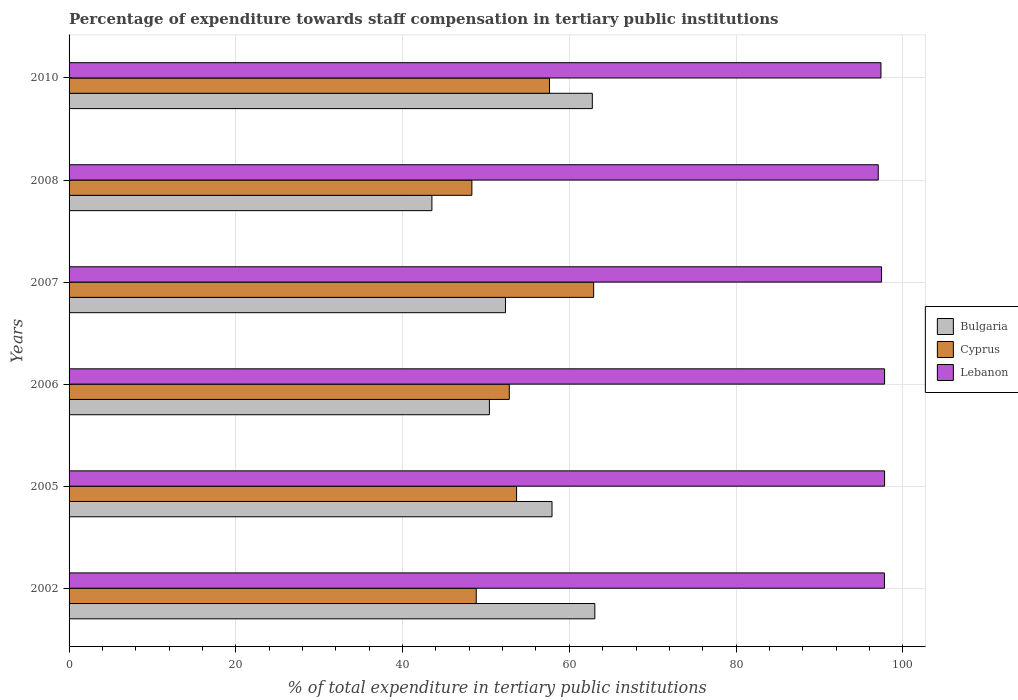Are the number of bars on each tick of the Y-axis equal?
Make the answer very short. Yes. How many bars are there on the 5th tick from the top?
Your answer should be compact. 3. How many bars are there on the 1st tick from the bottom?
Provide a succinct answer. 3. What is the label of the 4th group of bars from the top?
Give a very brief answer. 2006. What is the percentage of expenditure towards staff compensation in Cyprus in 2002?
Provide a short and direct response. 48.84. Across all years, what is the maximum percentage of expenditure towards staff compensation in Lebanon?
Provide a succinct answer. 97.81. Across all years, what is the minimum percentage of expenditure towards staff compensation in Lebanon?
Provide a short and direct response. 97.05. In which year was the percentage of expenditure towards staff compensation in Bulgaria minimum?
Make the answer very short. 2008. What is the total percentage of expenditure towards staff compensation in Lebanon in the graph?
Ensure brevity in your answer.  585.31. What is the difference between the percentage of expenditure towards staff compensation in Cyprus in 2006 and that in 2010?
Make the answer very short. -4.82. What is the difference between the percentage of expenditure towards staff compensation in Lebanon in 2006 and the percentage of expenditure towards staff compensation in Cyprus in 2007?
Make the answer very short. 34.89. What is the average percentage of expenditure towards staff compensation in Cyprus per year?
Your answer should be very brief. 54.03. In the year 2010, what is the difference between the percentage of expenditure towards staff compensation in Bulgaria and percentage of expenditure towards staff compensation in Cyprus?
Make the answer very short. 5.14. In how many years, is the percentage of expenditure towards staff compensation in Bulgaria greater than 32 %?
Ensure brevity in your answer.  6. What is the ratio of the percentage of expenditure towards staff compensation in Cyprus in 2002 to that in 2007?
Give a very brief answer. 0.78. Is the difference between the percentage of expenditure towards staff compensation in Bulgaria in 2006 and 2007 greater than the difference between the percentage of expenditure towards staff compensation in Cyprus in 2006 and 2007?
Ensure brevity in your answer.  Yes. What is the difference between the highest and the second highest percentage of expenditure towards staff compensation in Lebanon?
Your answer should be compact. 0. What is the difference between the highest and the lowest percentage of expenditure towards staff compensation in Lebanon?
Offer a terse response. 0.76. In how many years, is the percentage of expenditure towards staff compensation in Lebanon greater than the average percentage of expenditure towards staff compensation in Lebanon taken over all years?
Your answer should be compact. 3. What does the 1st bar from the bottom in 2008 represents?
Make the answer very short. Bulgaria. Is it the case that in every year, the sum of the percentage of expenditure towards staff compensation in Bulgaria and percentage of expenditure towards staff compensation in Cyprus is greater than the percentage of expenditure towards staff compensation in Lebanon?
Your response must be concise. No. Are all the bars in the graph horizontal?
Ensure brevity in your answer.  Yes. How many years are there in the graph?
Keep it short and to the point. 6. Are the values on the major ticks of X-axis written in scientific E-notation?
Make the answer very short. No. Does the graph contain any zero values?
Provide a short and direct response. No. Does the graph contain grids?
Make the answer very short. Yes. How many legend labels are there?
Offer a terse response. 3. How are the legend labels stacked?
Keep it short and to the point. Vertical. What is the title of the graph?
Keep it short and to the point. Percentage of expenditure towards staff compensation in tertiary public institutions. Does "Australia" appear as one of the legend labels in the graph?
Make the answer very short. No. What is the label or title of the X-axis?
Make the answer very short. % of total expenditure in tertiary public institutions. What is the % of total expenditure in tertiary public institutions of Bulgaria in 2002?
Your answer should be compact. 63.06. What is the % of total expenditure in tertiary public institutions in Cyprus in 2002?
Provide a succinct answer. 48.84. What is the % of total expenditure in tertiary public institutions in Lebanon in 2002?
Your response must be concise. 97.8. What is the % of total expenditure in tertiary public institutions in Bulgaria in 2005?
Keep it short and to the point. 57.93. What is the % of total expenditure in tertiary public institutions of Cyprus in 2005?
Make the answer very short. 53.68. What is the % of total expenditure in tertiary public institutions in Lebanon in 2005?
Give a very brief answer. 97.81. What is the % of total expenditure in tertiary public institutions of Bulgaria in 2006?
Provide a short and direct response. 50.42. What is the % of total expenditure in tertiary public institutions in Cyprus in 2006?
Offer a very short reply. 52.8. What is the % of total expenditure in tertiary public institutions in Lebanon in 2006?
Offer a terse response. 97.81. What is the % of total expenditure in tertiary public institutions in Bulgaria in 2007?
Your answer should be very brief. 52.34. What is the % of total expenditure in tertiary public institutions of Cyprus in 2007?
Give a very brief answer. 62.92. What is the % of total expenditure in tertiary public institutions in Lebanon in 2007?
Your response must be concise. 97.45. What is the % of total expenditure in tertiary public institutions in Bulgaria in 2008?
Offer a terse response. 43.52. What is the % of total expenditure in tertiary public institutions in Cyprus in 2008?
Keep it short and to the point. 48.31. What is the % of total expenditure in tertiary public institutions in Lebanon in 2008?
Offer a very short reply. 97.05. What is the % of total expenditure in tertiary public institutions of Bulgaria in 2010?
Keep it short and to the point. 62.76. What is the % of total expenditure in tertiary public institutions of Cyprus in 2010?
Your answer should be very brief. 57.62. What is the % of total expenditure in tertiary public institutions in Lebanon in 2010?
Provide a short and direct response. 97.38. Across all years, what is the maximum % of total expenditure in tertiary public institutions of Bulgaria?
Ensure brevity in your answer.  63.06. Across all years, what is the maximum % of total expenditure in tertiary public institutions in Cyprus?
Your answer should be compact. 62.92. Across all years, what is the maximum % of total expenditure in tertiary public institutions in Lebanon?
Your answer should be very brief. 97.81. Across all years, what is the minimum % of total expenditure in tertiary public institutions of Bulgaria?
Offer a terse response. 43.52. Across all years, what is the minimum % of total expenditure in tertiary public institutions in Cyprus?
Ensure brevity in your answer.  48.31. Across all years, what is the minimum % of total expenditure in tertiary public institutions in Lebanon?
Your answer should be very brief. 97.05. What is the total % of total expenditure in tertiary public institutions in Bulgaria in the graph?
Your answer should be compact. 330.02. What is the total % of total expenditure in tertiary public institutions in Cyprus in the graph?
Provide a succinct answer. 324.17. What is the total % of total expenditure in tertiary public institutions of Lebanon in the graph?
Your answer should be compact. 585.31. What is the difference between the % of total expenditure in tertiary public institutions of Bulgaria in 2002 and that in 2005?
Make the answer very short. 5.13. What is the difference between the % of total expenditure in tertiary public institutions in Cyprus in 2002 and that in 2005?
Ensure brevity in your answer.  -4.84. What is the difference between the % of total expenditure in tertiary public institutions of Lebanon in 2002 and that in 2005?
Keep it short and to the point. -0.02. What is the difference between the % of total expenditure in tertiary public institutions in Bulgaria in 2002 and that in 2006?
Provide a succinct answer. 12.64. What is the difference between the % of total expenditure in tertiary public institutions of Cyprus in 2002 and that in 2006?
Provide a succinct answer. -3.96. What is the difference between the % of total expenditure in tertiary public institutions of Lebanon in 2002 and that in 2006?
Your response must be concise. -0.02. What is the difference between the % of total expenditure in tertiary public institutions of Bulgaria in 2002 and that in 2007?
Your answer should be compact. 10.72. What is the difference between the % of total expenditure in tertiary public institutions in Cyprus in 2002 and that in 2007?
Offer a terse response. -14.08. What is the difference between the % of total expenditure in tertiary public institutions of Lebanon in 2002 and that in 2007?
Make the answer very short. 0.35. What is the difference between the % of total expenditure in tertiary public institutions in Bulgaria in 2002 and that in 2008?
Keep it short and to the point. 19.54. What is the difference between the % of total expenditure in tertiary public institutions of Cyprus in 2002 and that in 2008?
Offer a terse response. 0.52. What is the difference between the % of total expenditure in tertiary public institutions of Lebanon in 2002 and that in 2008?
Give a very brief answer. 0.74. What is the difference between the % of total expenditure in tertiary public institutions of Bulgaria in 2002 and that in 2010?
Your answer should be compact. 0.3. What is the difference between the % of total expenditure in tertiary public institutions in Cyprus in 2002 and that in 2010?
Offer a very short reply. -8.78. What is the difference between the % of total expenditure in tertiary public institutions of Lebanon in 2002 and that in 2010?
Offer a terse response. 0.42. What is the difference between the % of total expenditure in tertiary public institutions in Bulgaria in 2005 and that in 2006?
Offer a very short reply. 7.51. What is the difference between the % of total expenditure in tertiary public institutions in Cyprus in 2005 and that in 2006?
Your answer should be compact. 0.88. What is the difference between the % of total expenditure in tertiary public institutions of Lebanon in 2005 and that in 2006?
Keep it short and to the point. 0. What is the difference between the % of total expenditure in tertiary public institutions in Bulgaria in 2005 and that in 2007?
Your answer should be very brief. 5.58. What is the difference between the % of total expenditure in tertiary public institutions of Cyprus in 2005 and that in 2007?
Keep it short and to the point. -9.24. What is the difference between the % of total expenditure in tertiary public institutions of Lebanon in 2005 and that in 2007?
Give a very brief answer. 0.37. What is the difference between the % of total expenditure in tertiary public institutions of Bulgaria in 2005 and that in 2008?
Your response must be concise. 14.41. What is the difference between the % of total expenditure in tertiary public institutions of Cyprus in 2005 and that in 2008?
Give a very brief answer. 5.36. What is the difference between the % of total expenditure in tertiary public institutions in Lebanon in 2005 and that in 2008?
Keep it short and to the point. 0.76. What is the difference between the % of total expenditure in tertiary public institutions of Bulgaria in 2005 and that in 2010?
Make the answer very short. -4.83. What is the difference between the % of total expenditure in tertiary public institutions in Cyprus in 2005 and that in 2010?
Keep it short and to the point. -3.94. What is the difference between the % of total expenditure in tertiary public institutions of Lebanon in 2005 and that in 2010?
Make the answer very short. 0.43. What is the difference between the % of total expenditure in tertiary public institutions in Bulgaria in 2006 and that in 2007?
Keep it short and to the point. -1.93. What is the difference between the % of total expenditure in tertiary public institutions of Cyprus in 2006 and that in 2007?
Provide a succinct answer. -10.12. What is the difference between the % of total expenditure in tertiary public institutions of Lebanon in 2006 and that in 2007?
Your answer should be very brief. 0.37. What is the difference between the % of total expenditure in tertiary public institutions in Bulgaria in 2006 and that in 2008?
Make the answer very short. 6.9. What is the difference between the % of total expenditure in tertiary public institutions of Cyprus in 2006 and that in 2008?
Offer a very short reply. 4.49. What is the difference between the % of total expenditure in tertiary public institutions of Lebanon in 2006 and that in 2008?
Provide a succinct answer. 0.76. What is the difference between the % of total expenditure in tertiary public institutions of Bulgaria in 2006 and that in 2010?
Your answer should be compact. -12.34. What is the difference between the % of total expenditure in tertiary public institutions in Cyprus in 2006 and that in 2010?
Keep it short and to the point. -4.82. What is the difference between the % of total expenditure in tertiary public institutions in Lebanon in 2006 and that in 2010?
Your answer should be compact. 0.43. What is the difference between the % of total expenditure in tertiary public institutions in Bulgaria in 2007 and that in 2008?
Ensure brevity in your answer.  8.82. What is the difference between the % of total expenditure in tertiary public institutions in Cyprus in 2007 and that in 2008?
Keep it short and to the point. 14.61. What is the difference between the % of total expenditure in tertiary public institutions in Lebanon in 2007 and that in 2008?
Offer a very short reply. 0.39. What is the difference between the % of total expenditure in tertiary public institutions in Bulgaria in 2007 and that in 2010?
Offer a terse response. -10.42. What is the difference between the % of total expenditure in tertiary public institutions of Cyprus in 2007 and that in 2010?
Give a very brief answer. 5.3. What is the difference between the % of total expenditure in tertiary public institutions of Lebanon in 2007 and that in 2010?
Offer a terse response. 0.07. What is the difference between the % of total expenditure in tertiary public institutions in Bulgaria in 2008 and that in 2010?
Make the answer very short. -19.24. What is the difference between the % of total expenditure in tertiary public institutions of Cyprus in 2008 and that in 2010?
Keep it short and to the point. -9.31. What is the difference between the % of total expenditure in tertiary public institutions in Lebanon in 2008 and that in 2010?
Offer a very short reply. -0.33. What is the difference between the % of total expenditure in tertiary public institutions of Bulgaria in 2002 and the % of total expenditure in tertiary public institutions of Cyprus in 2005?
Provide a succinct answer. 9.38. What is the difference between the % of total expenditure in tertiary public institutions of Bulgaria in 2002 and the % of total expenditure in tertiary public institutions of Lebanon in 2005?
Provide a short and direct response. -34.76. What is the difference between the % of total expenditure in tertiary public institutions in Cyprus in 2002 and the % of total expenditure in tertiary public institutions in Lebanon in 2005?
Your answer should be very brief. -48.98. What is the difference between the % of total expenditure in tertiary public institutions of Bulgaria in 2002 and the % of total expenditure in tertiary public institutions of Cyprus in 2006?
Offer a terse response. 10.26. What is the difference between the % of total expenditure in tertiary public institutions of Bulgaria in 2002 and the % of total expenditure in tertiary public institutions of Lebanon in 2006?
Provide a succinct answer. -34.76. What is the difference between the % of total expenditure in tertiary public institutions in Cyprus in 2002 and the % of total expenditure in tertiary public institutions in Lebanon in 2006?
Offer a terse response. -48.98. What is the difference between the % of total expenditure in tertiary public institutions in Bulgaria in 2002 and the % of total expenditure in tertiary public institutions in Cyprus in 2007?
Make the answer very short. 0.14. What is the difference between the % of total expenditure in tertiary public institutions of Bulgaria in 2002 and the % of total expenditure in tertiary public institutions of Lebanon in 2007?
Your answer should be very brief. -34.39. What is the difference between the % of total expenditure in tertiary public institutions of Cyprus in 2002 and the % of total expenditure in tertiary public institutions of Lebanon in 2007?
Keep it short and to the point. -48.61. What is the difference between the % of total expenditure in tertiary public institutions in Bulgaria in 2002 and the % of total expenditure in tertiary public institutions in Cyprus in 2008?
Provide a short and direct response. 14.74. What is the difference between the % of total expenditure in tertiary public institutions in Bulgaria in 2002 and the % of total expenditure in tertiary public institutions in Lebanon in 2008?
Offer a very short reply. -34. What is the difference between the % of total expenditure in tertiary public institutions of Cyprus in 2002 and the % of total expenditure in tertiary public institutions of Lebanon in 2008?
Your response must be concise. -48.22. What is the difference between the % of total expenditure in tertiary public institutions of Bulgaria in 2002 and the % of total expenditure in tertiary public institutions of Cyprus in 2010?
Ensure brevity in your answer.  5.44. What is the difference between the % of total expenditure in tertiary public institutions of Bulgaria in 2002 and the % of total expenditure in tertiary public institutions of Lebanon in 2010?
Your response must be concise. -34.32. What is the difference between the % of total expenditure in tertiary public institutions in Cyprus in 2002 and the % of total expenditure in tertiary public institutions in Lebanon in 2010?
Make the answer very short. -48.54. What is the difference between the % of total expenditure in tertiary public institutions in Bulgaria in 2005 and the % of total expenditure in tertiary public institutions in Cyprus in 2006?
Make the answer very short. 5.12. What is the difference between the % of total expenditure in tertiary public institutions of Bulgaria in 2005 and the % of total expenditure in tertiary public institutions of Lebanon in 2006?
Your answer should be compact. -39.89. What is the difference between the % of total expenditure in tertiary public institutions of Cyprus in 2005 and the % of total expenditure in tertiary public institutions of Lebanon in 2006?
Your response must be concise. -44.14. What is the difference between the % of total expenditure in tertiary public institutions of Bulgaria in 2005 and the % of total expenditure in tertiary public institutions of Cyprus in 2007?
Your response must be concise. -4.99. What is the difference between the % of total expenditure in tertiary public institutions in Bulgaria in 2005 and the % of total expenditure in tertiary public institutions in Lebanon in 2007?
Your answer should be very brief. -39.52. What is the difference between the % of total expenditure in tertiary public institutions in Cyprus in 2005 and the % of total expenditure in tertiary public institutions in Lebanon in 2007?
Offer a very short reply. -43.77. What is the difference between the % of total expenditure in tertiary public institutions in Bulgaria in 2005 and the % of total expenditure in tertiary public institutions in Cyprus in 2008?
Offer a terse response. 9.61. What is the difference between the % of total expenditure in tertiary public institutions in Bulgaria in 2005 and the % of total expenditure in tertiary public institutions in Lebanon in 2008?
Provide a succinct answer. -39.13. What is the difference between the % of total expenditure in tertiary public institutions in Cyprus in 2005 and the % of total expenditure in tertiary public institutions in Lebanon in 2008?
Your answer should be very brief. -43.38. What is the difference between the % of total expenditure in tertiary public institutions of Bulgaria in 2005 and the % of total expenditure in tertiary public institutions of Cyprus in 2010?
Provide a short and direct response. 0.3. What is the difference between the % of total expenditure in tertiary public institutions of Bulgaria in 2005 and the % of total expenditure in tertiary public institutions of Lebanon in 2010?
Your answer should be compact. -39.45. What is the difference between the % of total expenditure in tertiary public institutions of Cyprus in 2005 and the % of total expenditure in tertiary public institutions of Lebanon in 2010?
Keep it short and to the point. -43.7. What is the difference between the % of total expenditure in tertiary public institutions of Bulgaria in 2006 and the % of total expenditure in tertiary public institutions of Cyprus in 2007?
Provide a succinct answer. -12.5. What is the difference between the % of total expenditure in tertiary public institutions of Bulgaria in 2006 and the % of total expenditure in tertiary public institutions of Lebanon in 2007?
Offer a very short reply. -47.03. What is the difference between the % of total expenditure in tertiary public institutions in Cyprus in 2006 and the % of total expenditure in tertiary public institutions in Lebanon in 2007?
Ensure brevity in your answer.  -44.65. What is the difference between the % of total expenditure in tertiary public institutions of Bulgaria in 2006 and the % of total expenditure in tertiary public institutions of Cyprus in 2008?
Give a very brief answer. 2.1. What is the difference between the % of total expenditure in tertiary public institutions in Bulgaria in 2006 and the % of total expenditure in tertiary public institutions in Lebanon in 2008?
Your answer should be very brief. -46.64. What is the difference between the % of total expenditure in tertiary public institutions of Cyprus in 2006 and the % of total expenditure in tertiary public institutions of Lebanon in 2008?
Offer a very short reply. -44.25. What is the difference between the % of total expenditure in tertiary public institutions in Bulgaria in 2006 and the % of total expenditure in tertiary public institutions in Cyprus in 2010?
Keep it short and to the point. -7.21. What is the difference between the % of total expenditure in tertiary public institutions in Bulgaria in 2006 and the % of total expenditure in tertiary public institutions in Lebanon in 2010?
Your answer should be compact. -46.96. What is the difference between the % of total expenditure in tertiary public institutions of Cyprus in 2006 and the % of total expenditure in tertiary public institutions of Lebanon in 2010?
Make the answer very short. -44.58. What is the difference between the % of total expenditure in tertiary public institutions in Bulgaria in 2007 and the % of total expenditure in tertiary public institutions in Cyprus in 2008?
Provide a succinct answer. 4.03. What is the difference between the % of total expenditure in tertiary public institutions of Bulgaria in 2007 and the % of total expenditure in tertiary public institutions of Lebanon in 2008?
Provide a short and direct response. -44.71. What is the difference between the % of total expenditure in tertiary public institutions of Cyprus in 2007 and the % of total expenditure in tertiary public institutions of Lebanon in 2008?
Give a very brief answer. -34.13. What is the difference between the % of total expenditure in tertiary public institutions of Bulgaria in 2007 and the % of total expenditure in tertiary public institutions of Cyprus in 2010?
Keep it short and to the point. -5.28. What is the difference between the % of total expenditure in tertiary public institutions in Bulgaria in 2007 and the % of total expenditure in tertiary public institutions in Lebanon in 2010?
Give a very brief answer. -45.04. What is the difference between the % of total expenditure in tertiary public institutions in Cyprus in 2007 and the % of total expenditure in tertiary public institutions in Lebanon in 2010?
Give a very brief answer. -34.46. What is the difference between the % of total expenditure in tertiary public institutions of Bulgaria in 2008 and the % of total expenditure in tertiary public institutions of Cyprus in 2010?
Keep it short and to the point. -14.1. What is the difference between the % of total expenditure in tertiary public institutions in Bulgaria in 2008 and the % of total expenditure in tertiary public institutions in Lebanon in 2010?
Offer a very short reply. -53.86. What is the difference between the % of total expenditure in tertiary public institutions in Cyprus in 2008 and the % of total expenditure in tertiary public institutions in Lebanon in 2010?
Your answer should be compact. -49.07. What is the average % of total expenditure in tertiary public institutions in Bulgaria per year?
Your response must be concise. 55. What is the average % of total expenditure in tertiary public institutions in Cyprus per year?
Your response must be concise. 54.03. What is the average % of total expenditure in tertiary public institutions of Lebanon per year?
Provide a succinct answer. 97.55. In the year 2002, what is the difference between the % of total expenditure in tertiary public institutions in Bulgaria and % of total expenditure in tertiary public institutions in Cyprus?
Provide a succinct answer. 14.22. In the year 2002, what is the difference between the % of total expenditure in tertiary public institutions of Bulgaria and % of total expenditure in tertiary public institutions of Lebanon?
Offer a very short reply. -34.74. In the year 2002, what is the difference between the % of total expenditure in tertiary public institutions in Cyprus and % of total expenditure in tertiary public institutions in Lebanon?
Offer a very short reply. -48.96. In the year 2005, what is the difference between the % of total expenditure in tertiary public institutions of Bulgaria and % of total expenditure in tertiary public institutions of Cyprus?
Offer a very short reply. 4.25. In the year 2005, what is the difference between the % of total expenditure in tertiary public institutions of Bulgaria and % of total expenditure in tertiary public institutions of Lebanon?
Provide a short and direct response. -39.89. In the year 2005, what is the difference between the % of total expenditure in tertiary public institutions in Cyprus and % of total expenditure in tertiary public institutions in Lebanon?
Keep it short and to the point. -44.14. In the year 2006, what is the difference between the % of total expenditure in tertiary public institutions in Bulgaria and % of total expenditure in tertiary public institutions in Cyprus?
Offer a terse response. -2.39. In the year 2006, what is the difference between the % of total expenditure in tertiary public institutions in Bulgaria and % of total expenditure in tertiary public institutions in Lebanon?
Offer a terse response. -47.4. In the year 2006, what is the difference between the % of total expenditure in tertiary public institutions of Cyprus and % of total expenditure in tertiary public institutions of Lebanon?
Ensure brevity in your answer.  -45.01. In the year 2007, what is the difference between the % of total expenditure in tertiary public institutions of Bulgaria and % of total expenditure in tertiary public institutions of Cyprus?
Give a very brief answer. -10.58. In the year 2007, what is the difference between the % of total expenditure in tertiary public institutions in Bulgaria and % of total expenditure in tertiary public institutions in Lebanon?
Give a very brief answer. -45.11. In the year 2007, what is the difference between the % of total expenditure in tertiary public institutions in Cyprus and % of total expenditure in tertiary public institutions in Lebanon?
Your answer should be compact. -34.53. In the year 2008, what is the difference between the % of total expenditure in tertiary public institutions of Bulgaria and % of total expenditure in tertiary public institutions of Cyprus?
Provide a succinct answer. -4.79. In the year 2008, what is the difference between the % of total expenditure in tertiary public institutions of Bulgaria and % of total expenditure in tertiary public institutions of Lebanon?
Provide a short and direct response. -53.53. In the year 2008, what is the difference between the % of total expenditure in tertiary public institutions in Cyprus and % of total expenditure in tertiary public institutions in Lebanon?
Provide a short and direct response. -48.74. In the year 2010, what is the difference between the % of total expenditure in tertiary public institutions of Bulgaria and % of total expenditure in tertiary public institutions of Cyprus?
Your answer should be compact. 5.14. In the year 2010, what is the difference between the % of total expenditure in tertiary public institutions of Bulgaria and % of total expenditure in tertiary public institutions of Lebanon?
Offer a very short reply. -34.62. In the year 2010, what is the difference between the % of total expenditure in tertiary public institutions of Cyprus and % of total expenditure in tertiary public institutions of Lebanon?
Make the answer very short. -39.76. What is the ratio of the % of total expenditure in tertiary public institutions of Bulgaria in 2002 to that in 2005?
Offer a very short reply. 1.09. What is the ratio of the % of total expenditure in tertiary public institutions in Cyprus in 2002 to that in 2005?
Make the answer very short. 0.91. What is the ratio of the % of total expenditure in tertiary public institutions of Lebanon in 2002 to that in 2005?
Keep it short and to the point. 1. What is the ratio of the % of total expenditure in tertiary public institutions of Bulgaria in 2002 to that in 2006?
Keep it short and to the point. 1.25. What is the ratio of the % of total expenditure in tertiary public institutions of Cyprus in 2002 to that in 2006?
Keep it short and to the point. 0.92. What is the ratio of the % of total expenditure in tertiary public institutions in Lebanon in 2002 to that in 2006?
Ensure brevity in your answer.  1. What is the ratio of the % of total expenditure in tertiary public institutions in Bulgaria in 2002 to that in 2007?
Give a very brief answer. 1.2. What is the ratio of the % of total expenditure in tertiary public institutions of Cyprus in 2002 to that in 2007?
Provide a succinct answer. 0.78. What is the ratio of the % of total expenditure in tertiary public institutions in Bulgaria in 2002 to that in 2008?
Give a very brief answer. 1.45. What is the ratio of the % of total expenditure in tertiary public institutions in Cyprus in 2002 to that in 2008?
Keep it short and to the point. 1.01. What is the ratio of the % of total expenditure in tertiary public institutions in Lebanon in 2002 to that in 2008?
Provide a short and direct response. 1.01. What is the ratio of the % of total expenditure in tertiary public institutions of Cyprus in 2002 to that in 2010?
Offer a terse response. 0.85. What is the ratio of the % of total expenditure in tertiary public institutions of Lebanon in 2002 to that in 2010?
Ensure brevity in your answer.  1. What is the ratio of the % of total expenditure in tertiary public institutions of Bulgaria in 2005 to that in 2006?
Provide a short and direct response. 1.15. What is the ratio of the % of total expenditure in tertiary public institutions of Cyprus in 2005 to that in 2006?
Keep it short and to the point. 1.02. What is the ratio of the % of total expenditure in tertiary public institutions of Bulgaria in 2005 to that in 2007?
Make the answer very short. 1.11. What is the ratio of the % of total expenditure in tertiary public institutions in Cyprus in 2005 to that in 2007?
Your answer should be very brief. 0.85. What is the ratio of the % of total expenditure in tertiary public institutions in Lebanon in 2005 to that in 2007?
Your response must be concise. 1. What is the ratio of the % of total expenditure in tertiary public institutions in Bulgaria in 2005 to that in 2008?
Keep it short and to the point. 1.33. What is the ratio of the % of total expenditure in tertiary public institutions in Cyprus in 2005 to that in 2008?
Keep it short and to the point. 1.11. What is the ratio of the % of total expenditure in tertiary public institutions of Lebanon in 2005 to that in 2008?
Your response must be concise. 1.01. What is the ratio of the % of total expenditure in tertiary public institutions in Bulgaria in 2005 to that in 2010?
Your answer should be compact. 0.92. What is the ratio of the % of total expenditure in tertiary public institutions in Cyprus in 2005 to that in 2010?
Your response must be concise. 0.93. What is the ratio of the % of total expenditure in tertiary public institutions of Lebanon in 2005 to that in 2010?
Your answer should be very brief. 1. What is the ratio of the % of total expenditure in tertiary public institutions in Bulgaria in 2006 to that in 2007?
Your answer should be compact. 0.96. What is the ratio of the % of total expenditure in tertiary public institutions in Cyprus in 2006 to that in 2007?
Your answer should be very brief. 0.84. What is the ratio of the % of total expenditure in tertiary public institutions in Bulgaria in 2006 to that in 2008?
Your answer should be very brief. 1.16. What is the ratio of the % of total expenditure in tertiary public institutions in Cyprus in 2006 to that in 2008?
Provide a succinct answer. 1.09. What is the ratio of the % of total expenditure in tertiary public institutions in Lebanon in 2006 to that in 2008?
Provide a succinct answer. 1.01. What is the ratio of the % of total expenditure in tertiary public institutions in Bulgaria in 2006 to that in 2010?
Your answer should be very brief. 0.8. What is the ratio of the % of total expenditure in tertiary public institutions in Cyprus in 2006 to that in 2010?
Provide a short and direct response. 0.92. What is the ratio of the % of total expenditure in tertiary public institutions of Bulgaria in 2007 to that in 2008?
Ensure brevity in your answer.  1.2. What is the ratio of the % of total expenditure in tertiary public institutions of Cyprus in 2007 to that in 2008?
Give a very brief answer. 1.3. What is the ratio of the % of total expenditure in tertiary public institutions of Lebanon in 2007 to that in 2008?
Your answer should be compact. 1. What is the ratio of the % of total expenditure in tertiary public institutions in Bulgaria in 2007 to that in 2010?
Ensure brevity in your answer.  0.83. What is the ratio of the % of total expenditure in tertiary public institutions of Cyprus in 2007 to that in 2010?
Give a very brief answer. 1.09. What is the ratio of the % of total expenditure in tertiary public institutions in Bulgaria in 2008 to that in 2010?
Provide a succinct answer. 0.69. What is the ratio of the % of total expenditure in tertiary public institutions in Cyprus in 2008 to that in 2010?
Give a very brief answer. 0.84. What is the difference between the highest and the second highest % of total expenditure in tertiary public institutions in Bulgaria?
Offer a terse response. 0.3. What is the difference between the highest and the second highest % of total expenditure in tertiary public institutions in Cyprus?
Make the answer very short. 5.3. What is the difference between the highest and the second highest % of total expenditure in tertiary public institutions in Lebanon?
Your response must be concise. 0. What is the difference between the highest and the lowest % of total expenditure in tertiary public institutions in Bulgaria?
Give a very brief answer. 19.54. What is the difference between the highest and the lowest % of total expenditure in tertiary public institutions in Cyprus?
Your answer should be very brief. 14.61. What is the difference between the highest and the lowest % of total expenditure in tertiary public institutions in Lebanon?
Give a very brief answer. 0.76. 